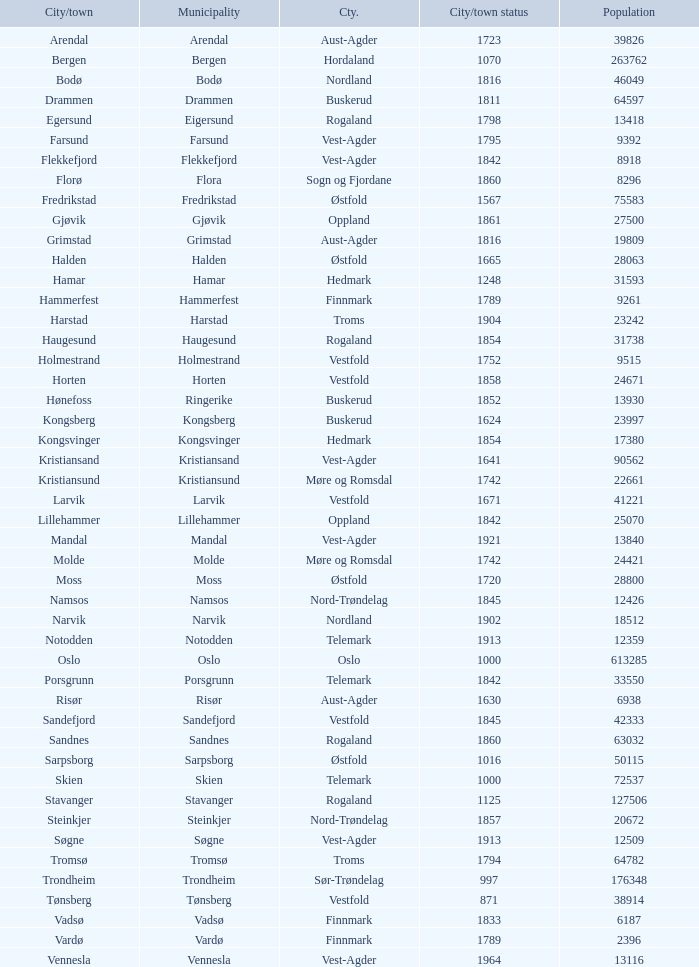In the municipality of moss, what are the names of the cities or towns? Moss. 